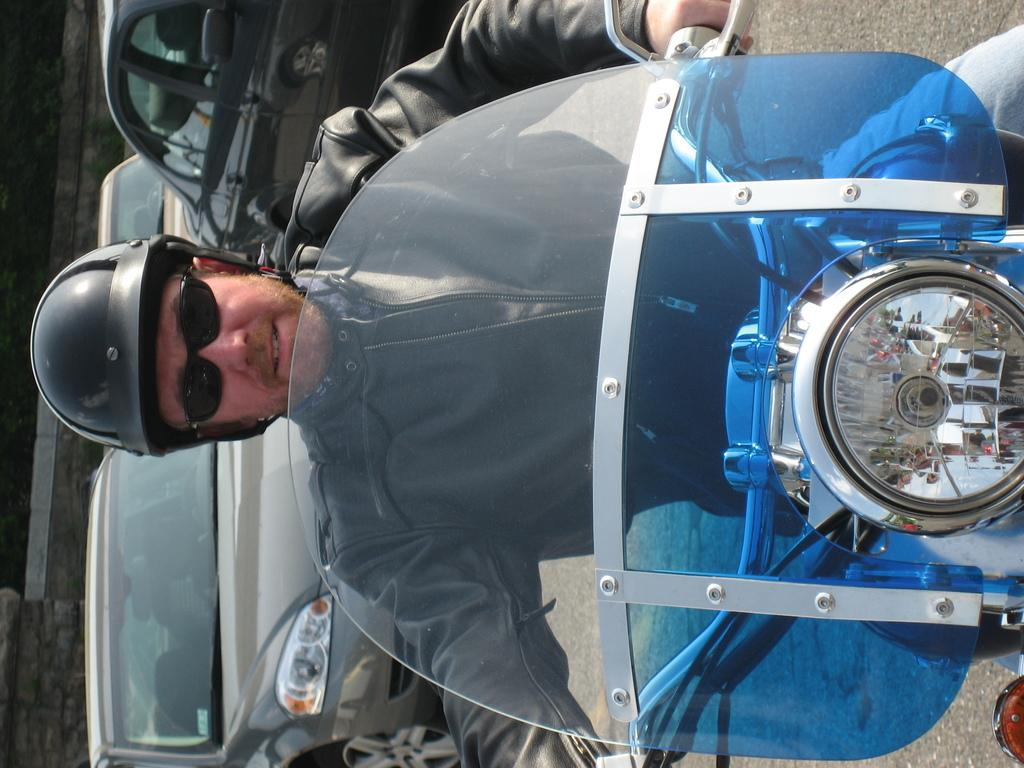What is the main subject of the image? There is a person in the image. What is the person wearing? The person is wearing a black jacket and a black helmet. What activity is the person engaged in? The person is riding a motorbike. What can be seen in the background of the image? There are other vehicles visible in the background of the image. What type of iron is being used to generate ideas in the image? There is no iron or idea generation visible in the image; it features a person riding a motorbike with other vehicles in the background. 